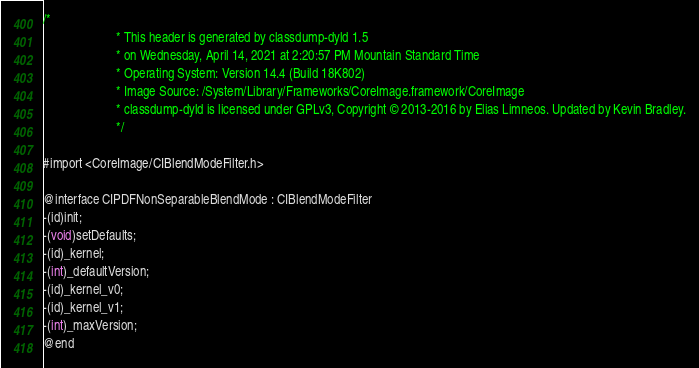<code> <loc_0><loc_0><loc_500><loc_500><_C_>/*
                       * This header is generated by classdump-dyld 1.5
                       * on Wednesday, April 14, 2021 at 2:20:57 PM Mountain Standard Time
                       * Operating System: Version 14.4 (Build 18K802)
                       * Image Source: /System/Library/Frameworks/CoreImage.framework/CoreImage
                       * classdump-dyld is licensed under GPLv3, Copyright © 2013-2016 by Elias Limneos. Updated by Kevin Bradley.
                       */

#import <CoreImage/CIBlendModeFilter.h>

@interface CIPDFNonSeparableBlendMode : CIBlendModeFilter
-(id)init;
-(void)setDefaults;
-(id)_kernel;
-(int)_defaultVersion;
-(id)_kernel_v0;
-(id)_kernel_v1;
-(int)_maxVersion;
@end

</code> 